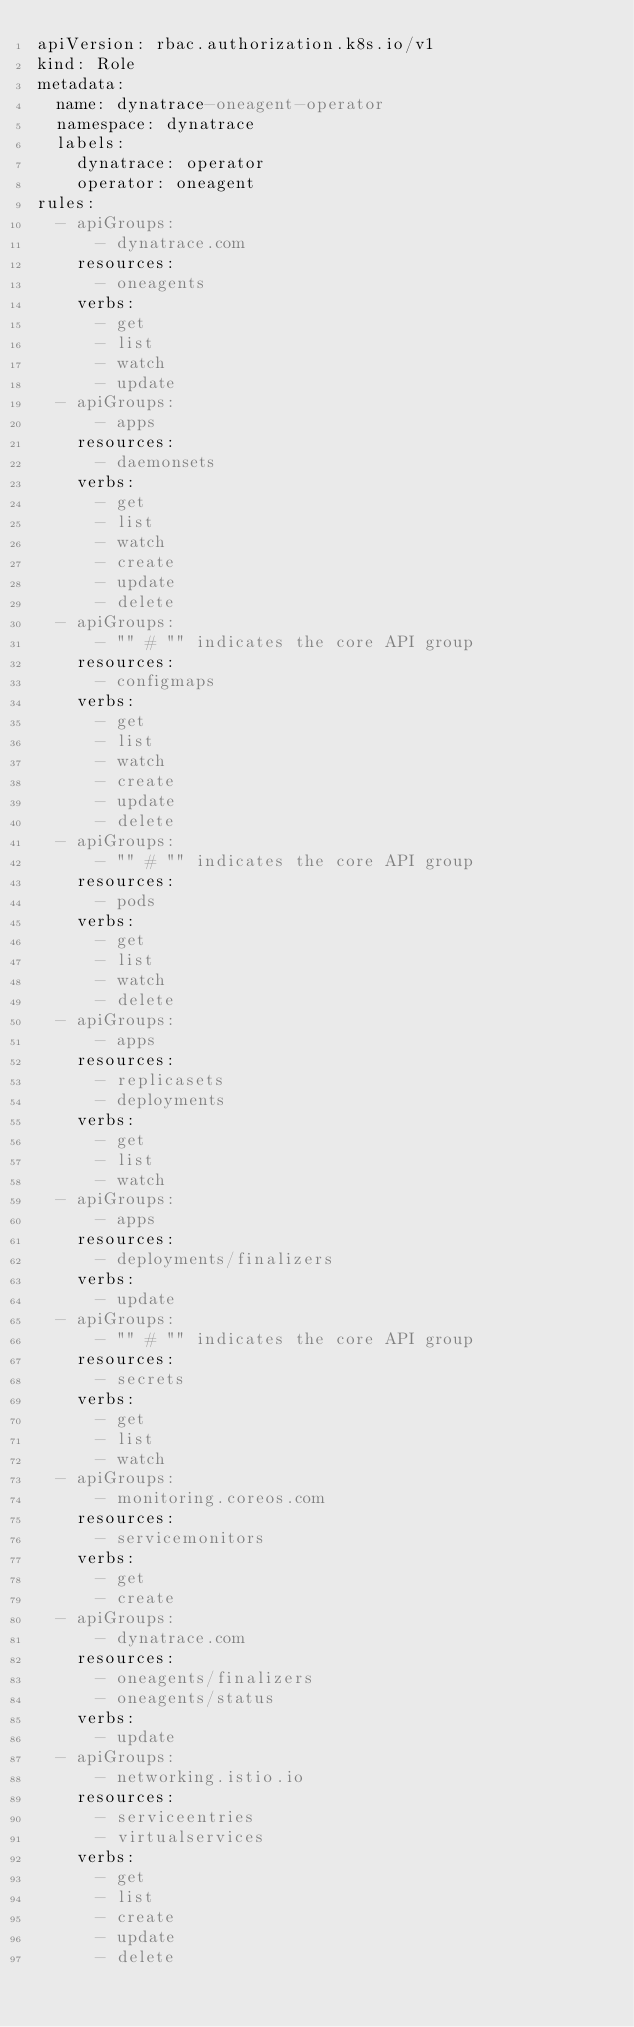Convert code to text. <code><loc_0><loc_0><loc_500><loc_500><_YAML_>apiVersion: rbac.authorization.k8s.io/v1
kind: Role
metadata:
  name: dynatrace-oneagent-operator
  namespace: dynatrace
  labels:
    dynatrace: operator
    operator: oneagent
rules:
  - apiGroups:
      - dynatrace.com
    resources:
      - oneagents
    verbs:
      - get
      - list
      - watch
      - update
  - apiGroups:
      - apps
    resources:
      - daemonsets
    verbs:
      - get
      - list
      - watch
      - create
      - update
      - delete
  - apiGroups:
      - "" # "" indicates the core API group
    resources:
      - configmaps
    verbs:
      - get
      - list
      - watch
      - create
      - update
      - delete
  - apiGroups:
      - "" # "" indicates the core API group
    resources:
      - pods
    verbs:
      - get
      - list
      - watch
      - delete
  - apiGroups:
      - apps
    resources:
      - replicasets
      - deployments
    verbs:
      - get
      - list
      - watch
  - apiGroups:
      - apps
    resources:
      - deployments/finalizers
    verbs:
      - update
  - apiGroups:
      - "" # "" indicates the core API group
    resources:
      - secrets
    verbs:
      - get
      - list
      - watch
  - apiGroups:
      - monitoring.coreos.com
    resources:
      - servicemonitors
    verbs:
      - get
      - create
  - apiGroups:
      - dynatrace.com
    resources:
      - oneagents/finalizers
      - oneagents/status
    verbs:
      - update
  - apiGroups:
      - networking.istio.io
    resources:
      - serviceentries
      - virtualservices
    verbs:
      - get
      - list
      - create
      - update
      - delete
</code> 